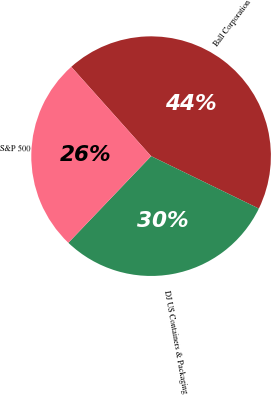Convert chart to OTSL. <chart><loc_0><loc_0><loc_500><loc_500><pie_chart><fcel>Ball Corporation<fcel>DJ US Containers & Packaging<fcel>S&P 500<nl><fcel>43.82%<fcel>29.93%<fcel>26.26%<nl></chart> 